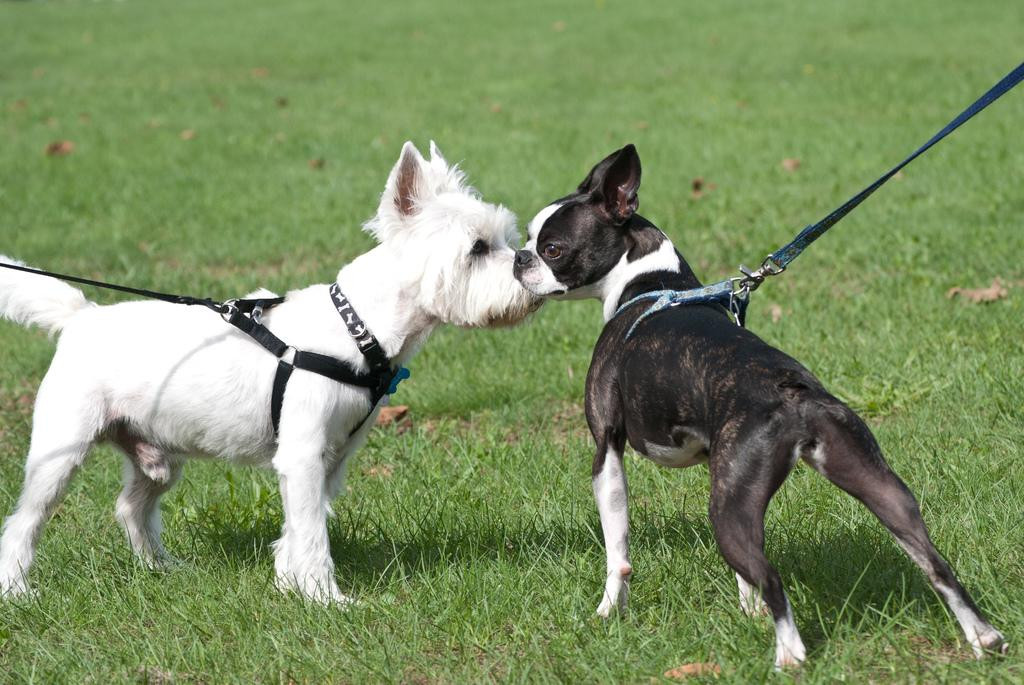What animals can be seen in the image? There are dogs in the image. What is the position of the dogs in the image? The dogs are standing on the ground. What are the dogs wearing in the image? There are dog belts around the dogs. How are the dog belts connected to the dogs? There is a leash attached to the dog belts. What type of surface is the dogs standing on? There is grass on the ground. Can you read the writing on the sign in the image? There is no sign present in the image, so there is no writing to read. 